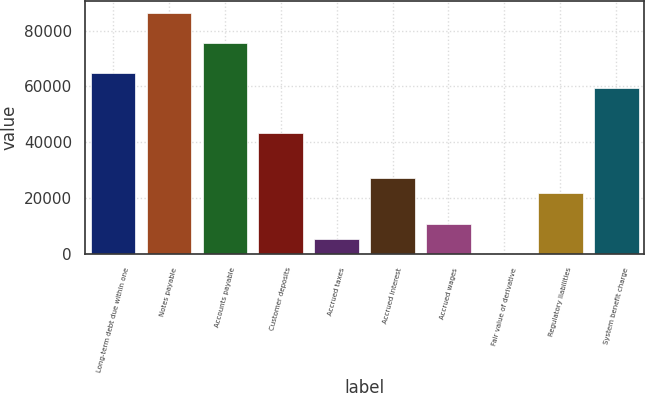Convert chart. <chart><loc_0><loc_0><loc_500><loc_500><bar_chart><fcel>Long-term debt due within one<fcel>Notes payable<fcel>Accounts payable<fcel>Customer deposits<fcel>Accrued taxes<fcel>Accrued interest<fcel>Accrued wages<fcel>Fair value of derivative<fcel>Regulatory liabilities<fcel>System benefit charge<nl><fcel>64694<fcel>86242<fcel>75468<fcel>43146<fcel>5437<fcel>26985<fcel>10824<fcel>50<fcel>21598<fcel>59307<nl></chart> 